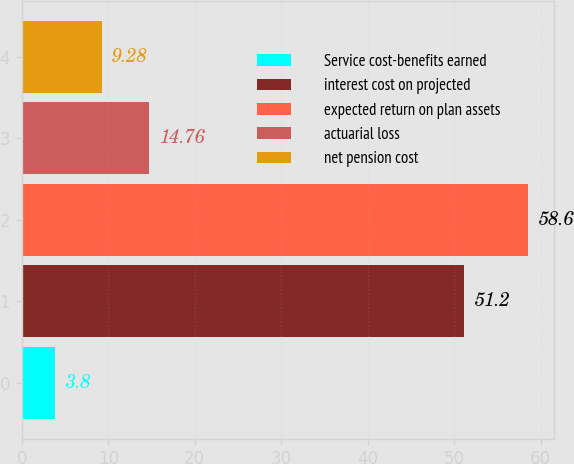Convert chart to OTSL. <chart><loc_0><loc_0><loc_500><loc_500><bar_chart><fcel>Service cost-benefits earned<fcel>interest cost on projected<fcel>expected return on plan assets<fcel>actuarial loss<fcel>net pension cost<nl><fcel>3.8<fcel>51.2<fcel>58.6<fcel>14.76<fcel>9.28<nl></chart> 